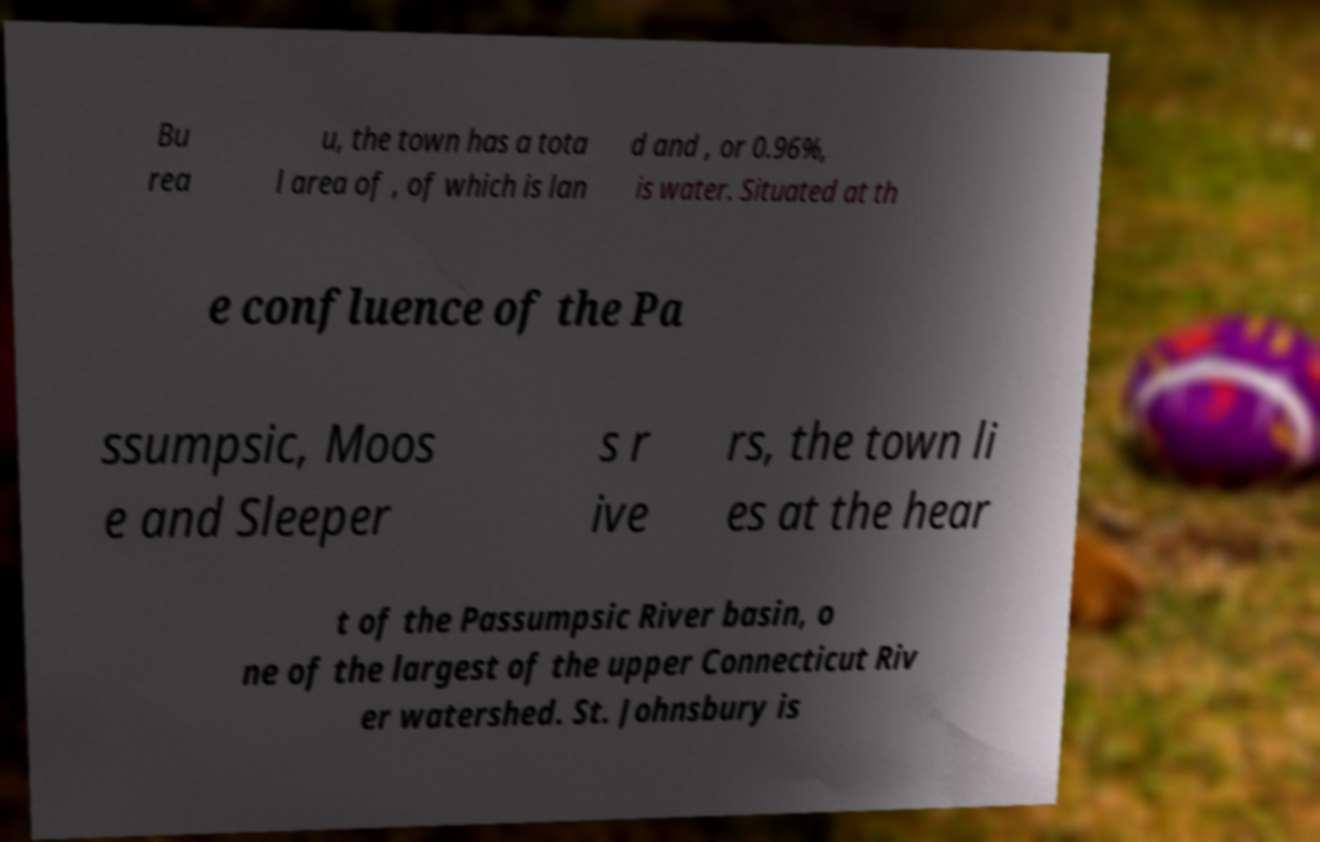Please read and relay the text visible in this image. What does it say? Bu rea u, the town has a tota l area of , of which is lan d and , or 0.96%, is water. Situated at th e confluence of the Pa ssumpsic, Moos e and Sleeper s r ive rs, the town li es at the hear t of the Passumpsic River basin, o ne of the largest of the upper Connecticut Riv er watershed. St. Johnsbury is 